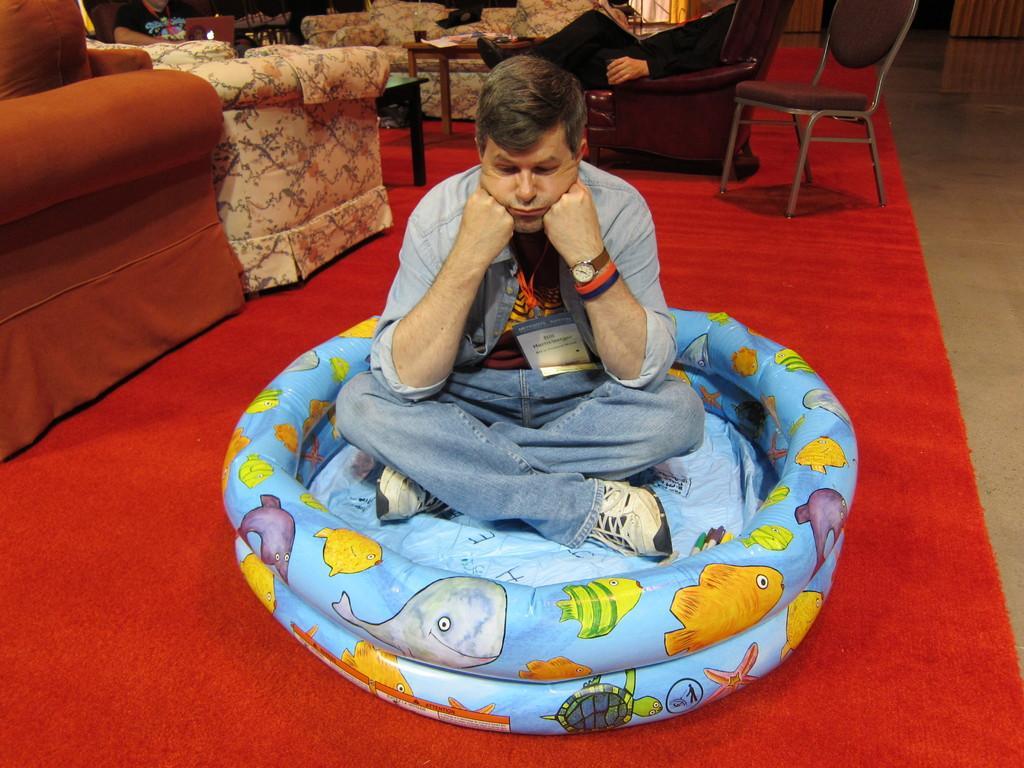In one or two sentences, can you explain what this image depicts? In this picture we can see man sitting on balloon type tub with hands keeping to his cheeks and in background we can see person sitting on chair, sofa, table, mattress. 